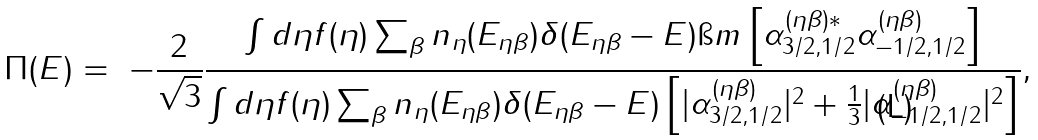<formula> <loc_0><loc_0><loc_500><loc_500>\Pi ( E ) = \ - \frac { 2 } { \sqrt { 3 } } \frac { \int d \eta f ( \eta ) \sum _ { \beta } n _ { \eta } ( E _ { \eta \beta } ) \delta ( E _ { \eta \beta } - E ) \i m \left [ \alpha _ { 3 / 2 , 1 / 2 } ^ { ( \eta \beta ) * } \alpha _ { - 1 / 2 , 1 / 2 } ^ { ( \eta \beta ) } \right ] } { \int d \eta f ( \eta ) \sum _ { \beta } n _ { \eta } ( E _ { \eta \beta } ) \delta ( E _ { \eta \beta } - E ) \left [ | \alpha _ { 3 / 2 , 1 / 2 } ^ { ( \eta \beta ) } | ^ { 2 } + \frac { 1 } { 3 } | \alpha _ { - 1 / 2 , 1 / 2 } ^ { ( \eta \beta ) } | ^ { 2 } \right ] } ,</formula> 